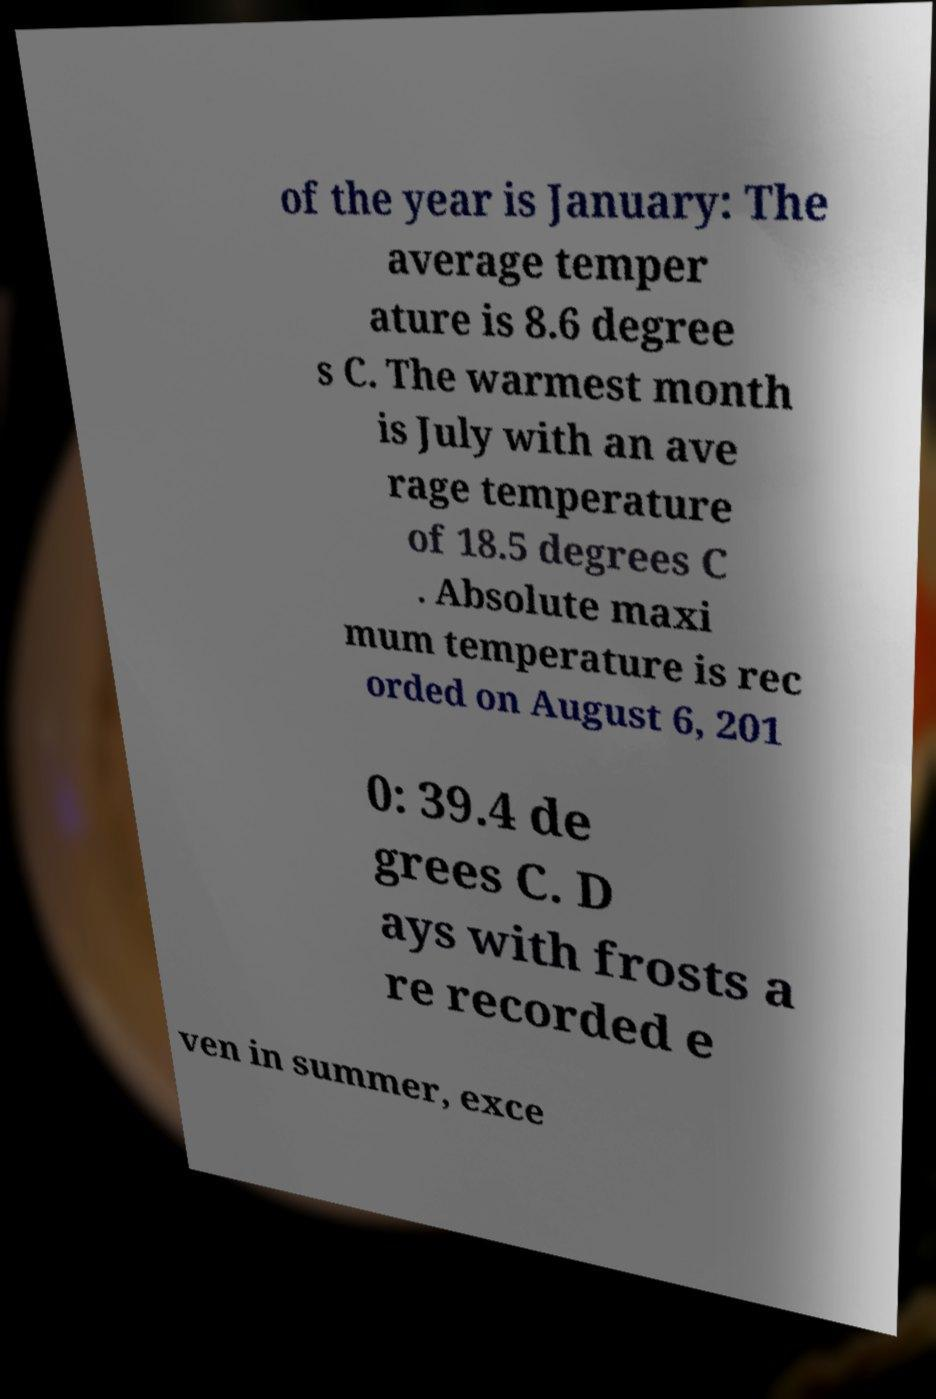Please read and relay the text visible in this image. What does it say? of the year is January: The average temper ature is 8.6 degree s C. The warmest month is July with an ave rage temperature of 18.5 degrees C . Absolute maxi mum temperature is rec orded on August 6, 201 0: 39.4 de grees C. D ays with frosts a re recorded e ven in summer, exce 